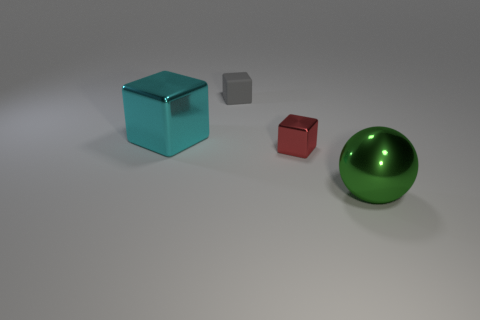Add 2 gray things. How many objects exist? 6 Subtract all balls. How many objects are left? 3 Add 3 green balls. How many green balls are left? 4 Add 3 purple metallic cylinders. How many purple metallic cylinders exist? 3 Subtract 0 purple cylinders. How many objects are left? 4 Subtract all small blocks. Subtract all big cyan objects. How many objects are left? 1 